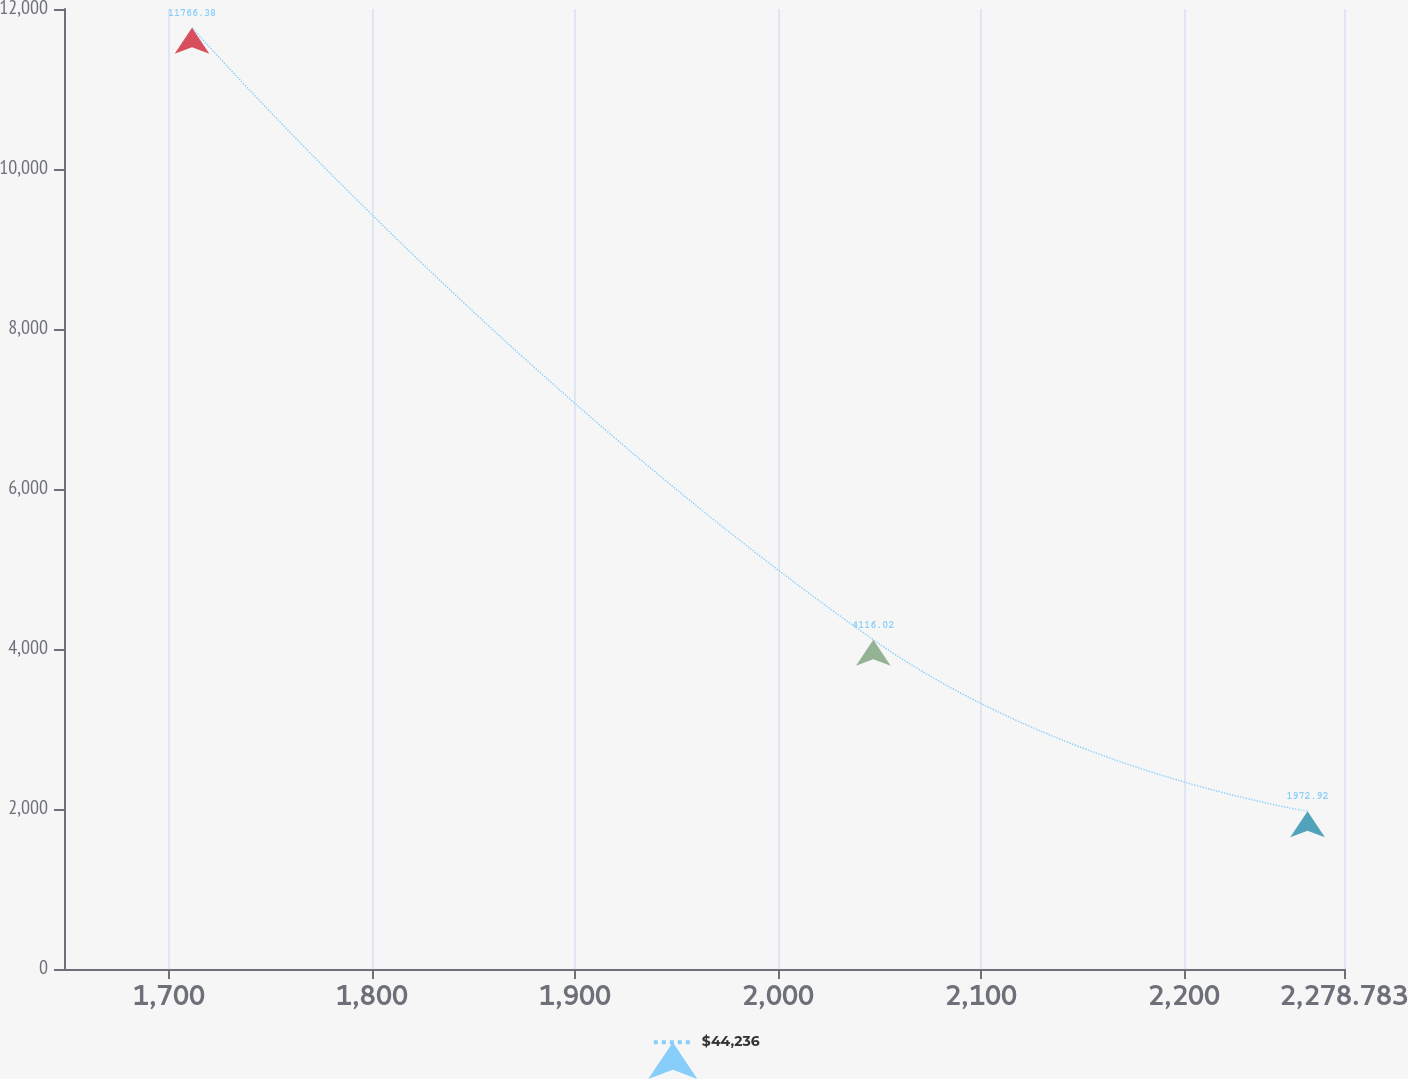<chart> <loc_0><loc_0><loc_500><loc_500><line_chart><ecel><fcel>$44,236<nl><fcel>1711.36<fcel>11766.4<nl><fcel>2046.95<fcel>4116.02<nl><fcel>2260.82<fcel>1972.92<nl><fcel>2341.83<fcel>2952.27<nl></chart> 